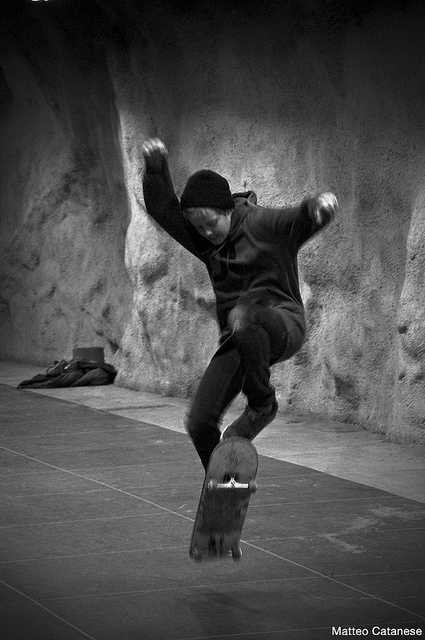<image>Where this guy is playing with board? I don't know where this guy is playing with the board. It could be a park, a cave, sidewalk, skate park, street, inside or outside. Where this guy is playing with board? I don't know where this guy is playing with board. It can be seen in park, cave, skateboard, sidewalk, skate park, street, inside or outside. 